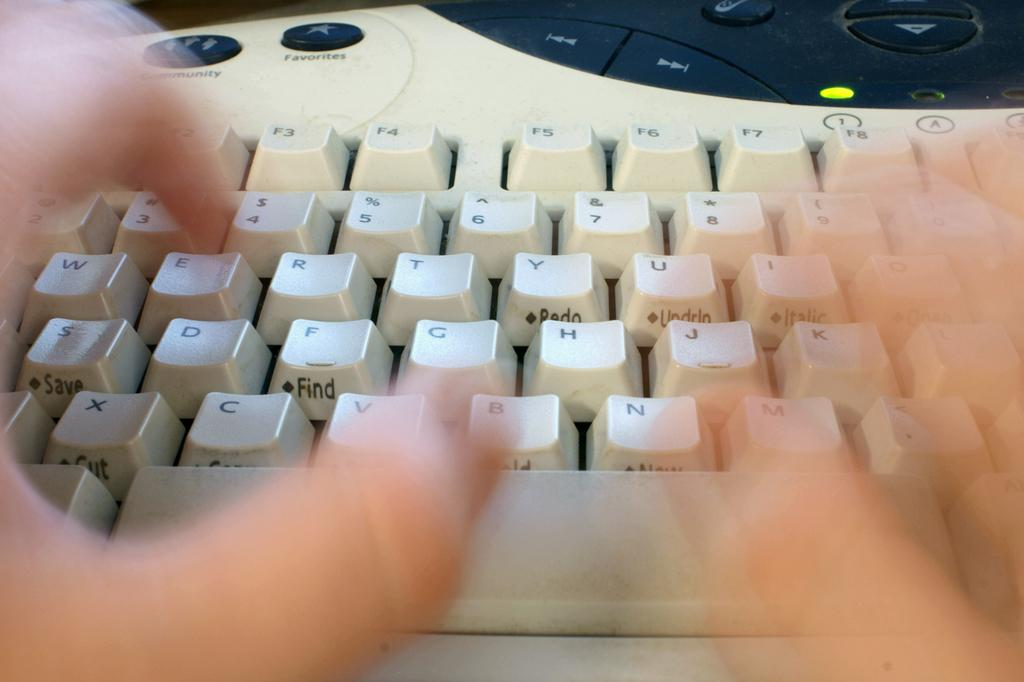<image>
Provide a brief description of the given image. A keyboard featuring two blurry hands above alphabet keys and blue buttons that say "community"  and "favorites on the keyboard. 